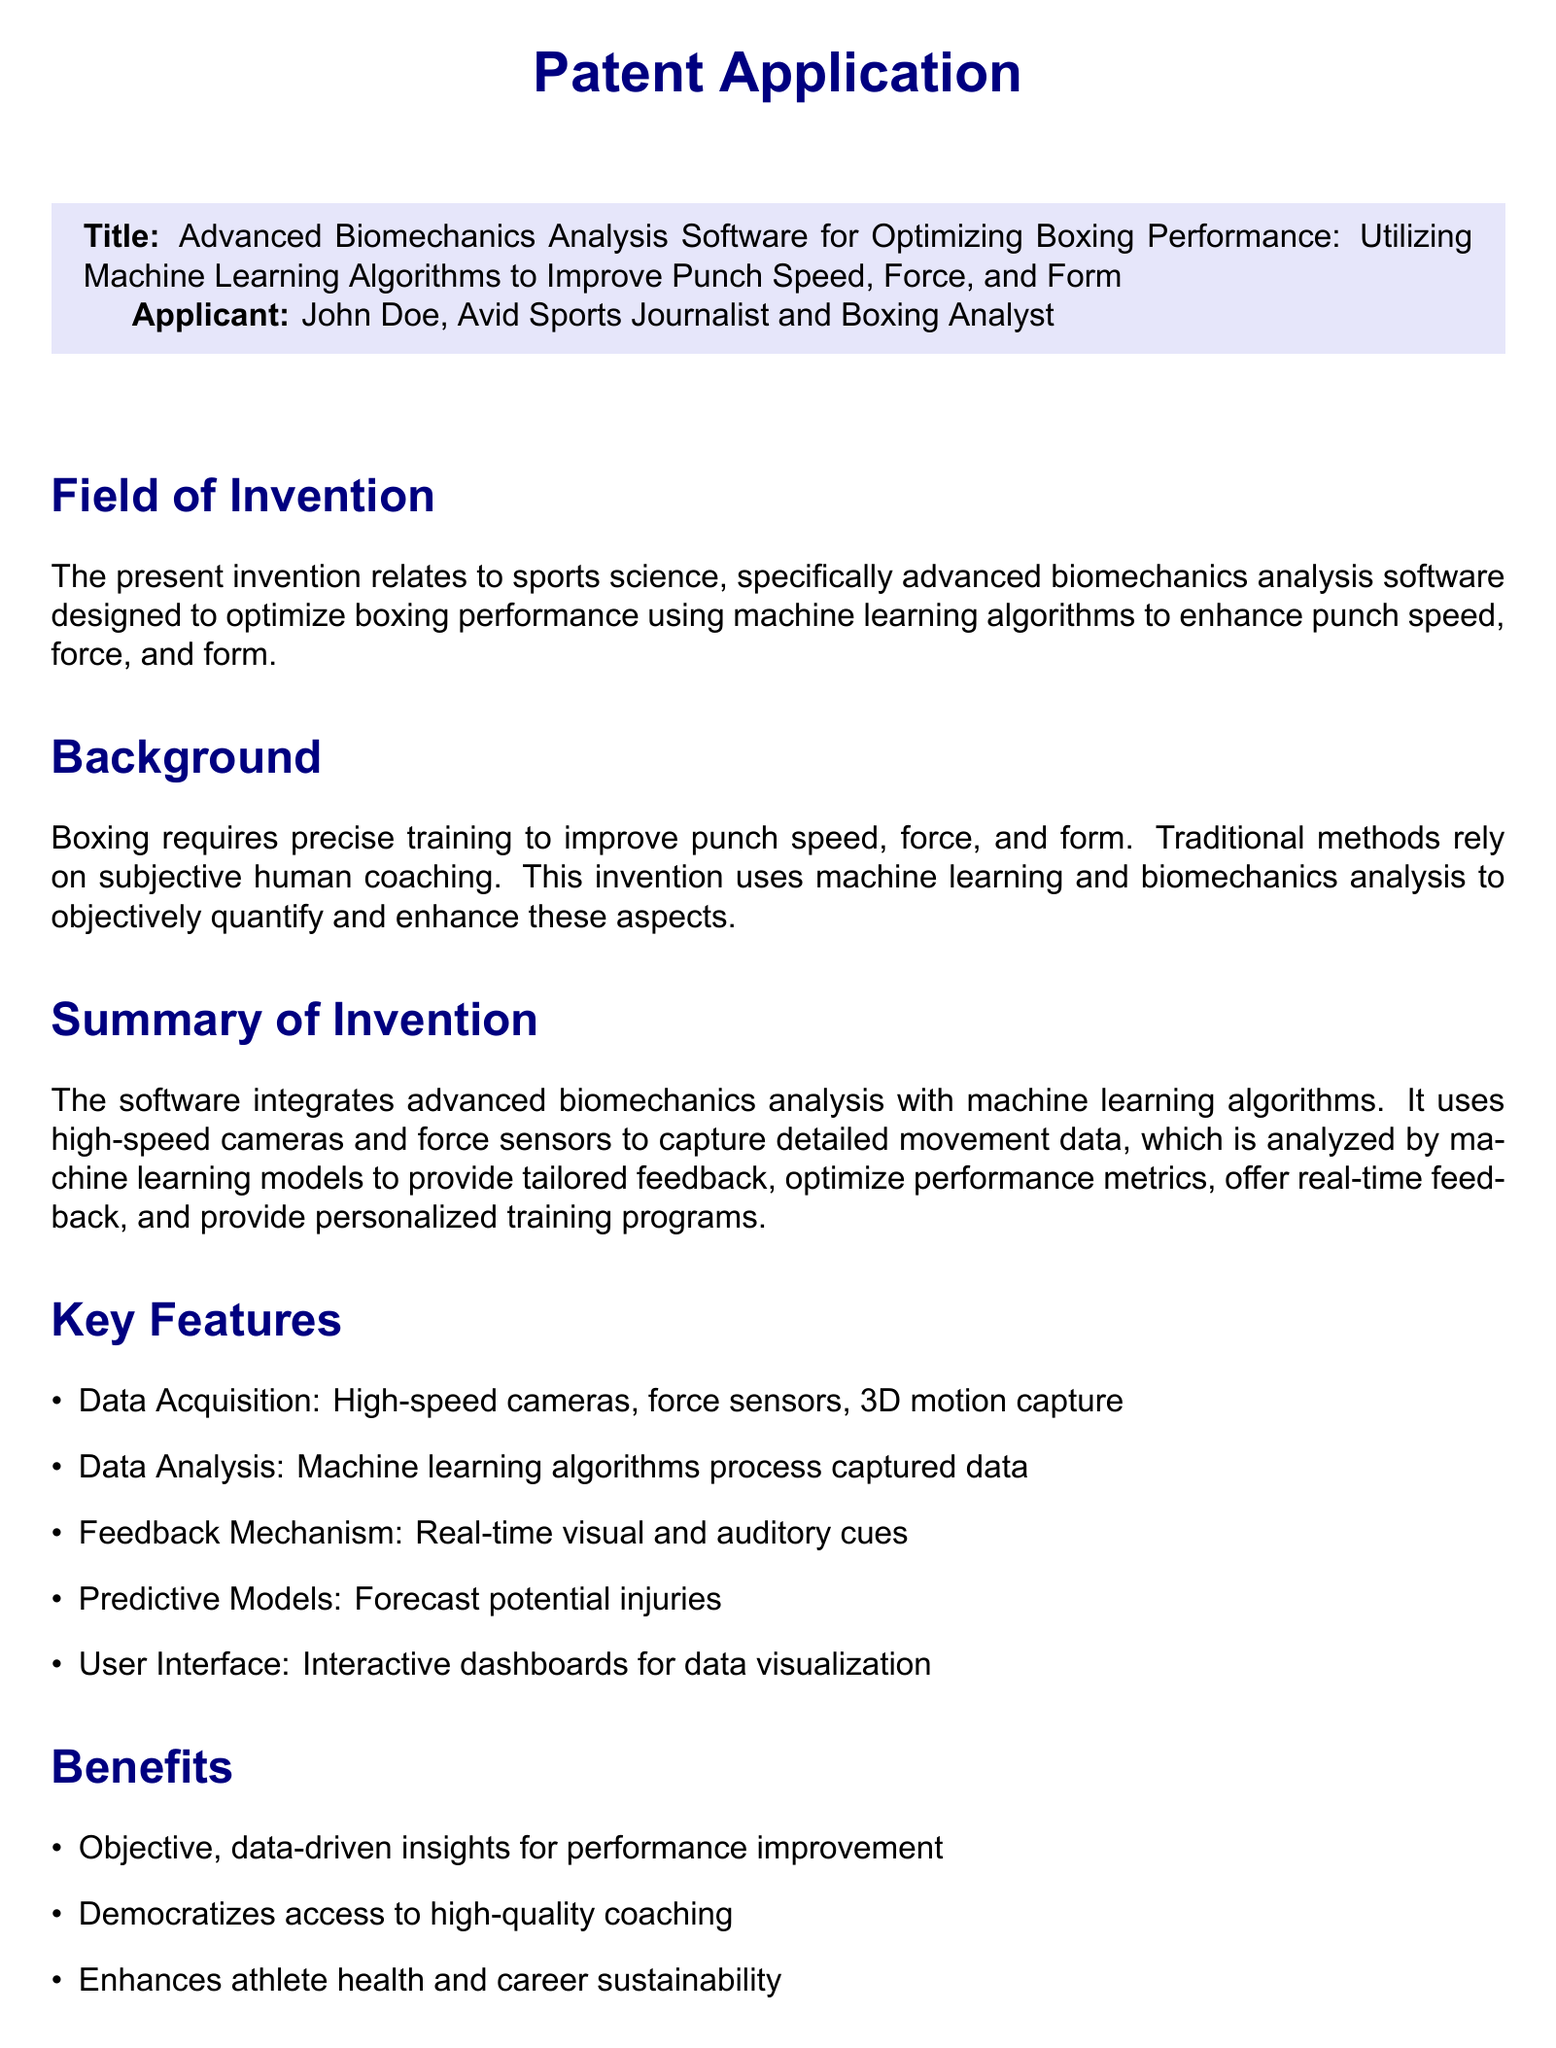What is the title of the patent application? The title is specified at the beginning of the patent application section.
Answer: Advanced Biomechanics Analysis Software for Optimizing Boxing Performance: Utilizing Machine Learning Algorithms to Improve Punch Speed, Force, and Form Who is the applicant of the patent? The applicant's name is mentioned right after the title in the patent application.
Answer: John Doe What technology is used for data acquisition? The key features section lists the technologies utilized for data acquisition.
Answer: High-speed cameras, force sensors, 3D motion capture Which algorithms are utilized in the software? The summary of invention mentions the type of algorithms used within the software.
Answer: Machine learning algorithms What does the predictive model forecast? The claims section describes the purpose of the predictive models included in the software.
Answer: Potential injuries How many key features are listed in the document? The key features section contains a bullet list that can be easily counted.
Answer: Five What is one benefit of using this software? The benefits section outlines the advantages of implementing the software for athletes.
Answer: Objective, data-driven insights for performance improvement What is the funding source mentioned in the document? The funding sources are listed at the end of the patent application.
Answer: NIH, NSF 